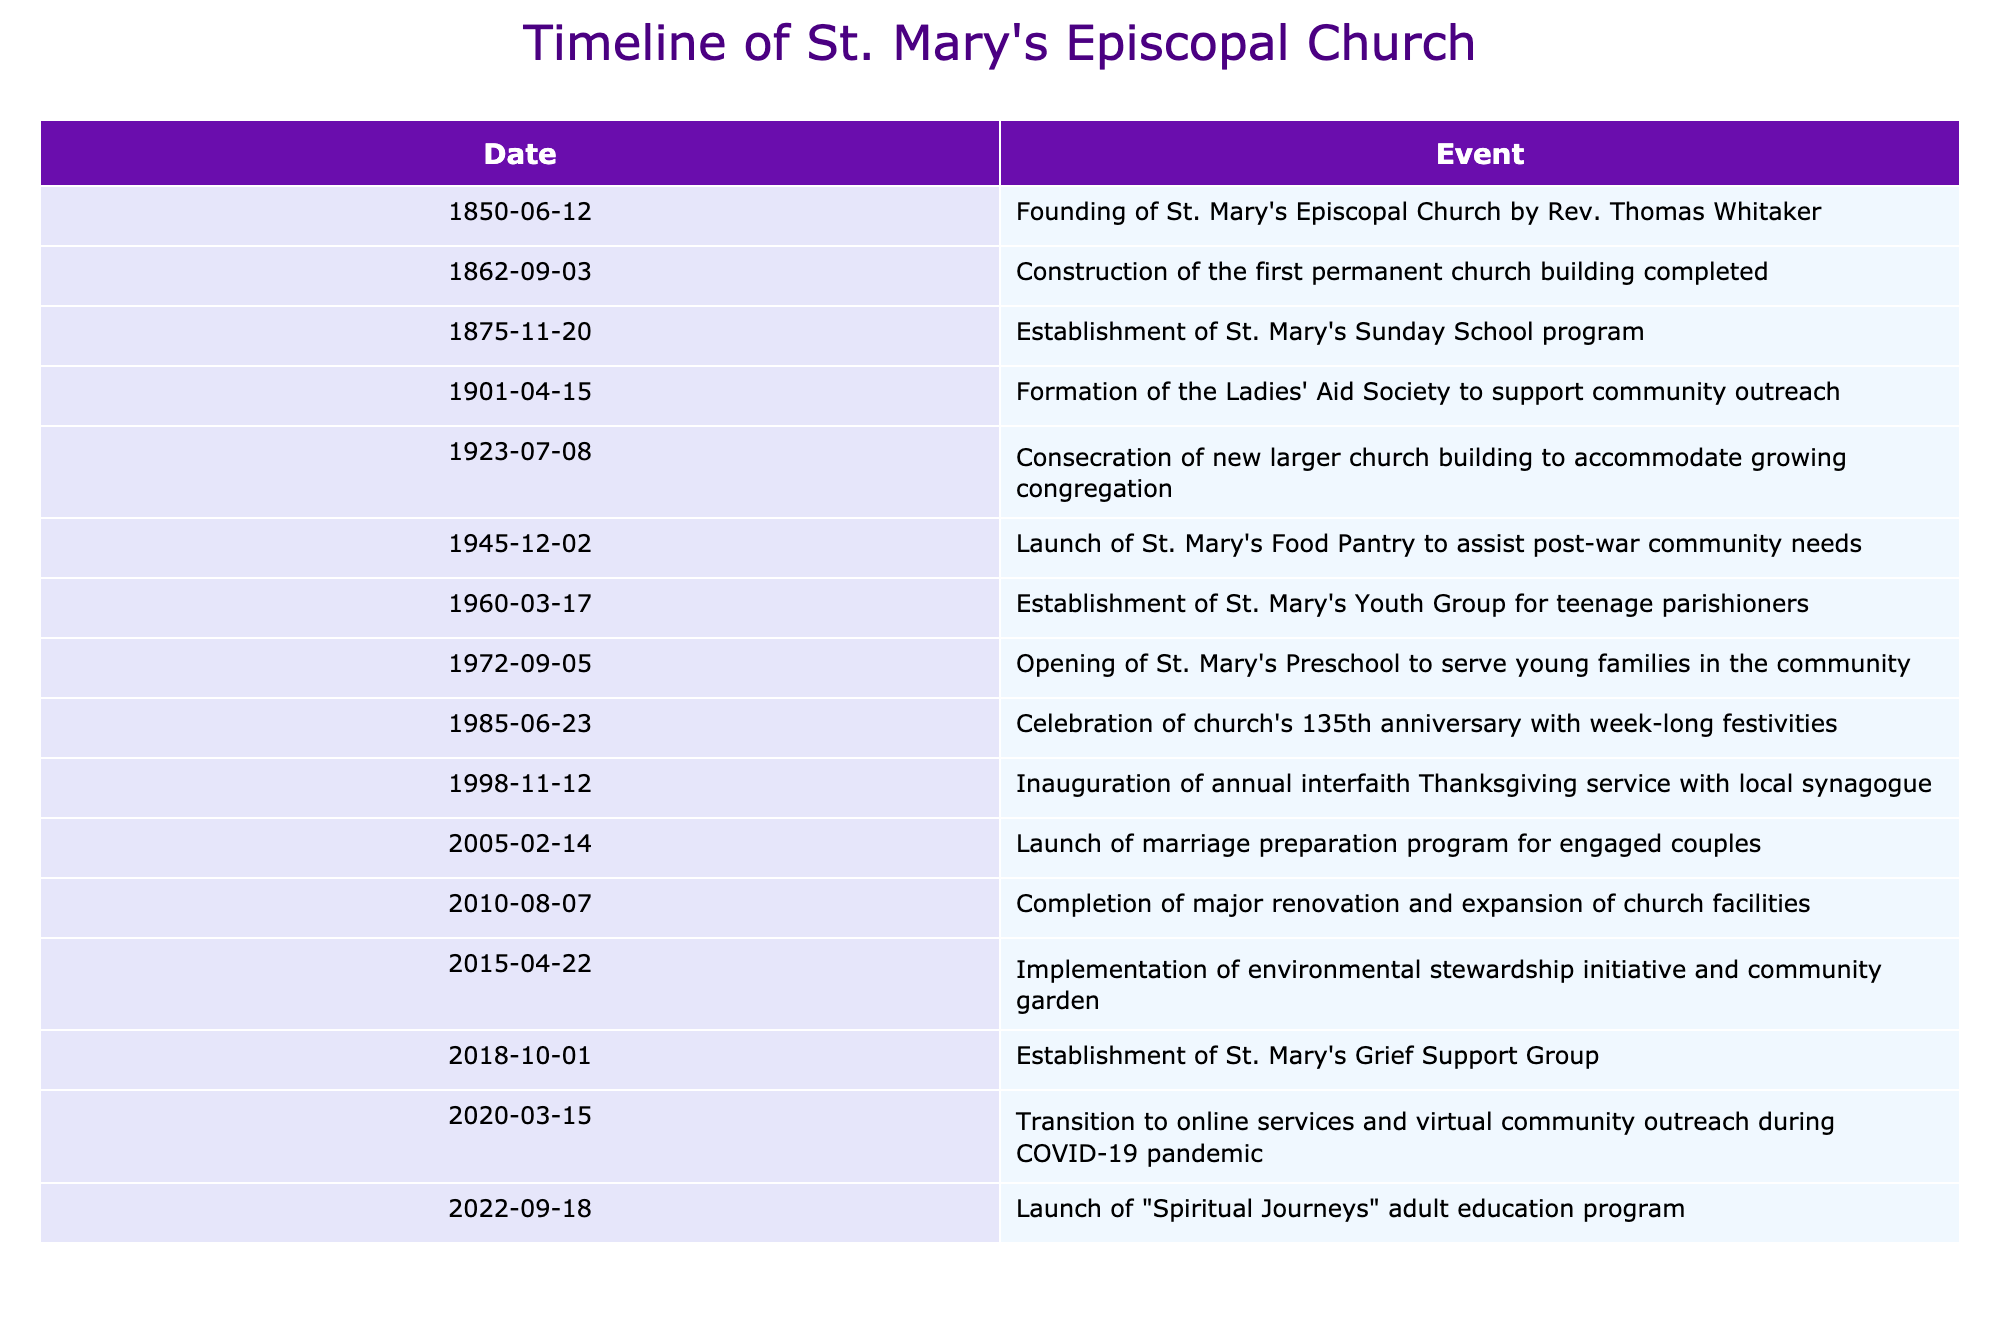What was the founding date of St. Mary's Episcopal Church? The table shows that St. Mary's Episcopal Church was founded on June 12, 1850, as indicated in the first row of the timeline.
Answer: June 12, 1850 When was the food pantry launched? According to the table, the food pantry was launched on December 2, 1945, as listed under the corresponding date.
Answer: December 2, 1945 How many years passed between the founding of the church and the establishment of the Sunday School program? The church was founded in 1850, and the Sunday School program was established in 1875. The difference is 1875 - 1850 = 25 years.
Answer: 25 years Did St. Mary's Episcopal Church have a youth group established before 1970? The table indicates that the youth group was established on March 17, 1960. Therefore, before 1970, St. Mary’s had a youth group.
Answer: Yes What significant event happened in 2020? The table notes that in 2020, on March 15, there was a transition to online services and virtual community outreach during the COVID-19 pandemic, indicating a significant shift in church operations due to the ongoing circumstances.
Answer: Transition to online services What percentage of the events listed occurred before 2000? There are 15 events in total, with 10 of them occurring before 2000. To find the percentage, calculate (10/15) * 100 = 66.67%.
Answer: 66.67% What can be inferred about the growth of St. Mary's Episcopal Church based on the timeline? The timeline lists various milestones such as the construction of a larger church building in 1923 and the launch of programs like the food pantry, youth group, and grief support group, which suggest active engagement in community needs and growth in congregation size over time. One can infer that as the community grew, so did the church’s initiatives to meet those needs.
Answer: The church expanded its facilities and programs to support community growth 